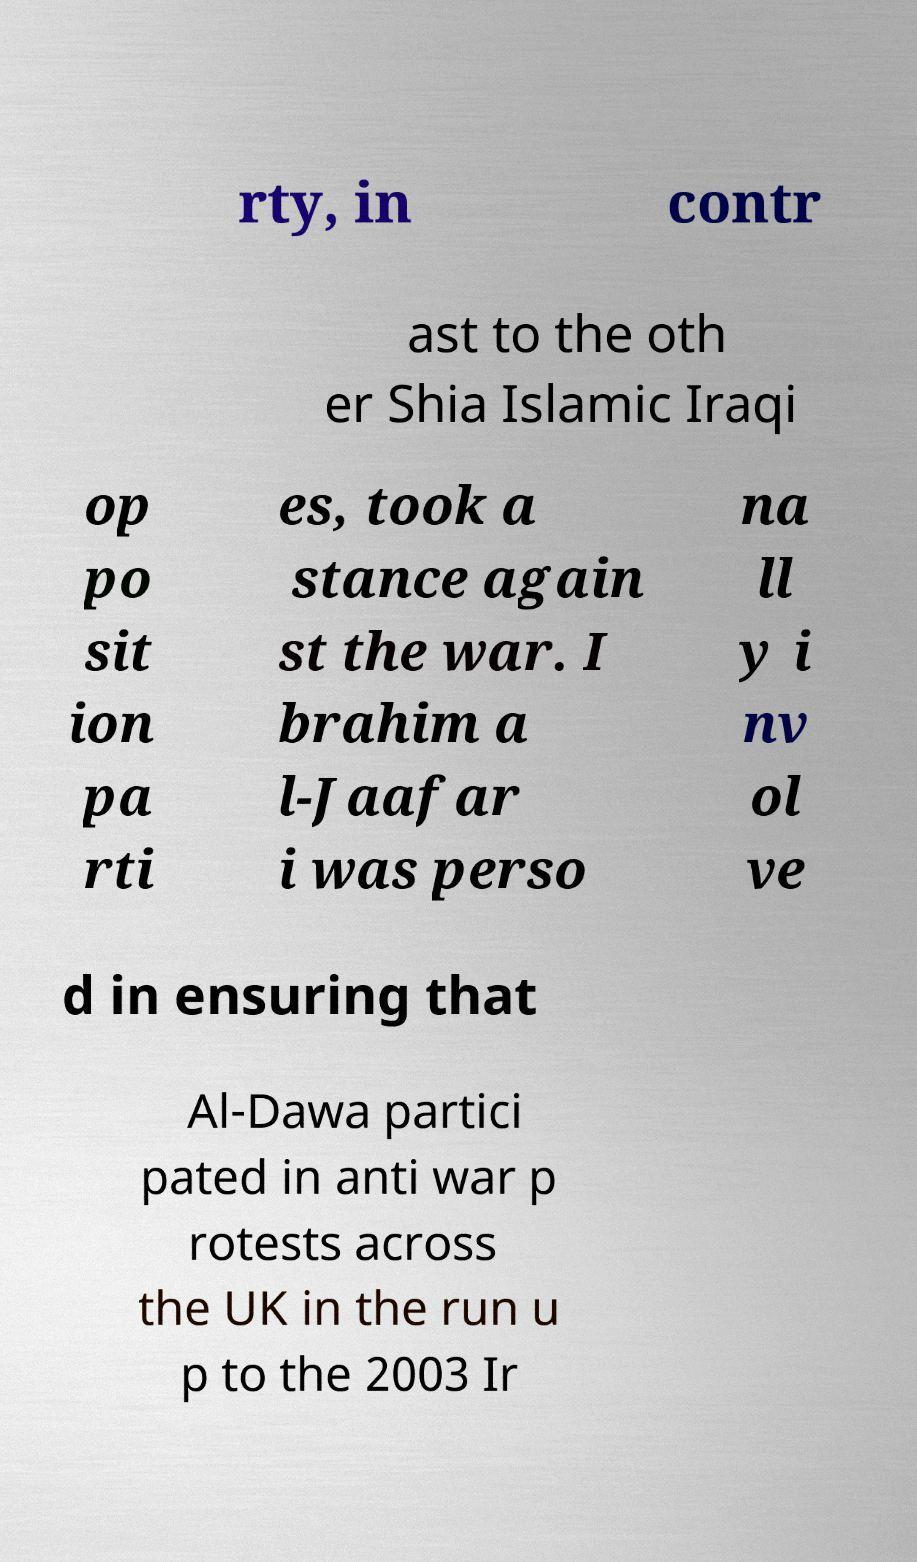I need the written content from this picture converted into text. Can you do that? rty, in contr ast to the oth er Shia Islamic Iraqi op po sit ion pa rti es, took a stance again st the war. I brahim a l-Jaafar i was perso na ll y i nv ol ve d in ensuring that Al-Dawa partici pated in anti war p rotests across the UK in the run u p to the 2003 Ir 